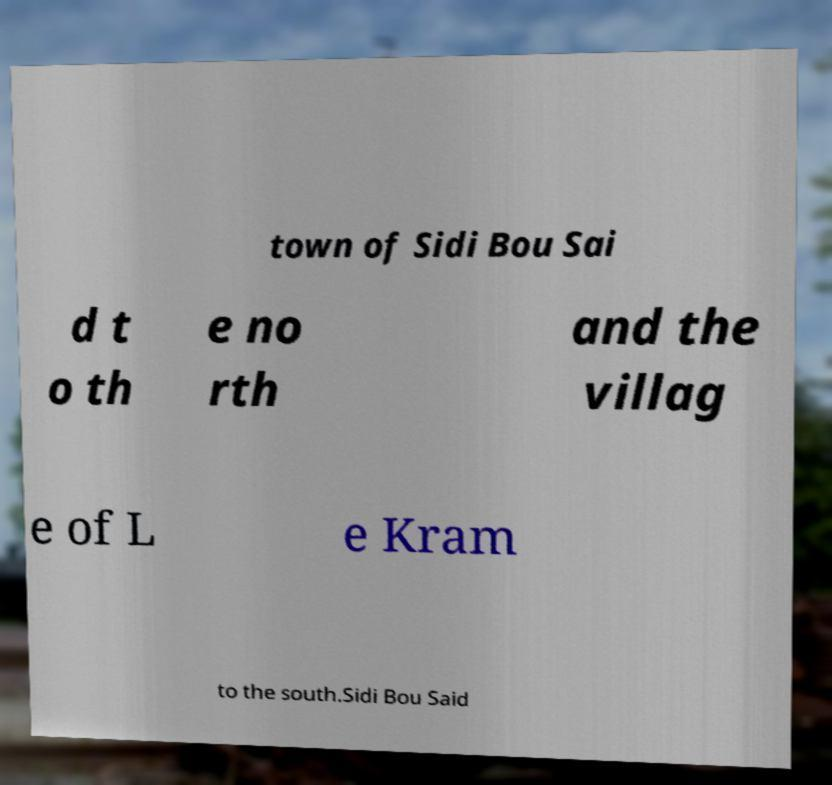I need the written content from this picture converted into text. Can you do that? town of Sidi Bou Sai d t o th e no rth and the villag e of L e Kram to the south.Sidi Bou Said 